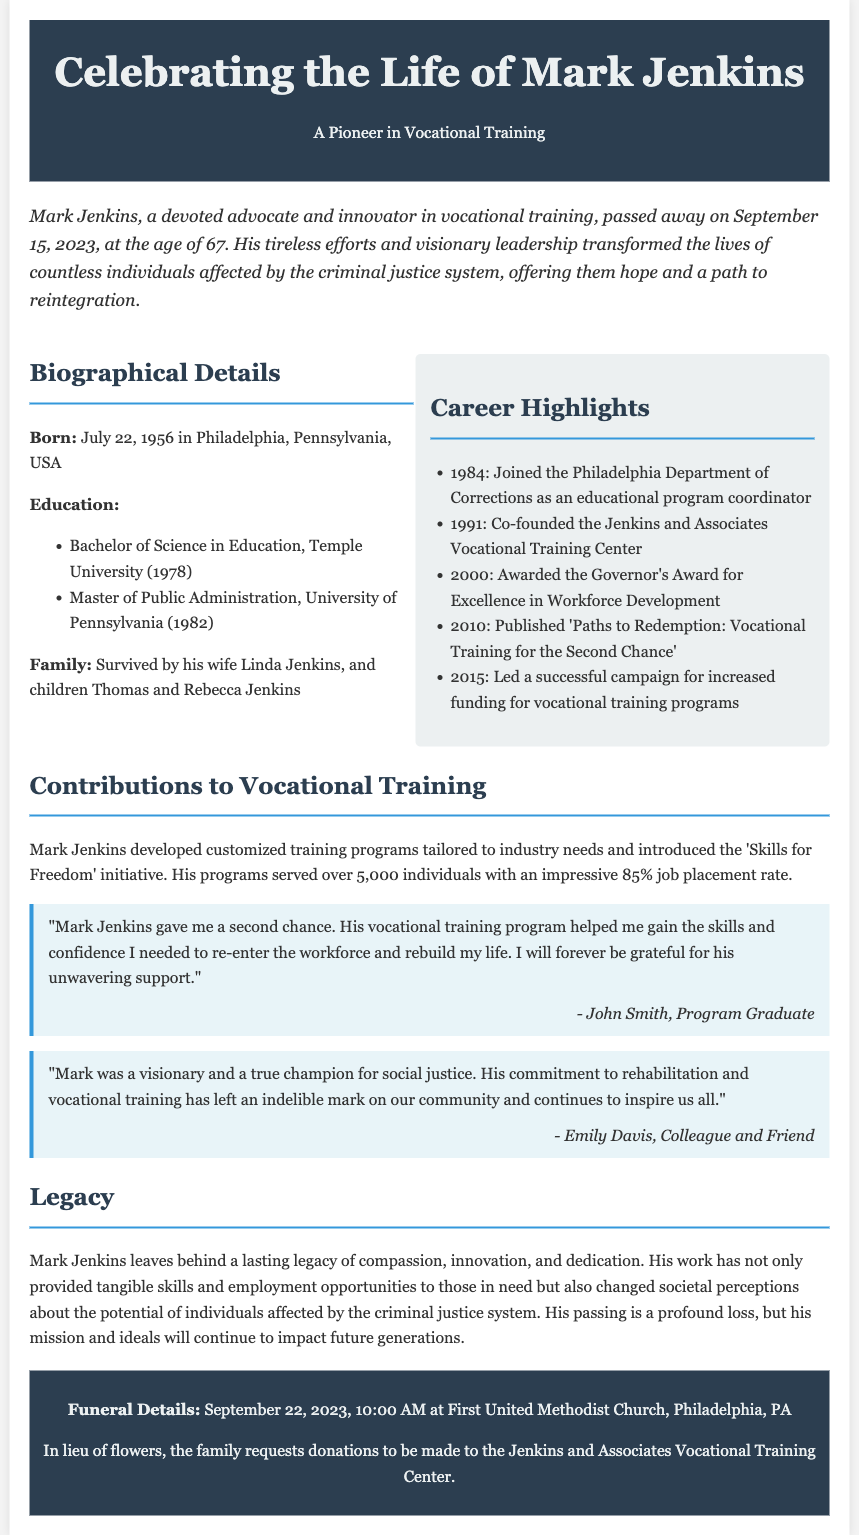what was Mark Jenkins' age at the time of his passing? Mark Jenkins passed away at the age of 67 on September 15, 2023.
Answer: 67 what initiative did Mark Jenkins introduce? The document mentions the 'Skills for Freedom' initiative as introduced by Mark Jenkins.
Answer: Skills for Freedom which university did Mark Jenkins attend for his undergraduate degree? The obituary lists Temple University as the institution where he received his Bachelor's degree in Education.
Answer: Temple University how many individuals benefited from Mark Jenkins' programs? According to the document, over 5,000 individuals were served by his programs.
Answer: 5,000 when is the funeral service scheduled? The funeral details specify that it is on September 22, 2023, at 10:00 AM.
Answer: September 22, 2023 what was the job placement rate for the vocational training programs? The document states that the job placement rate was 85%.
Answer: 85% who is Mark Jenkins' surviving spouse? The document mentions Linda Jenkins as his surviving spouse.
Answer: Linda Jenkins which award did Mark Jenkins receive in 2000? The Governor's Award for Excellence in Workforce Development is mentioned as an award he received.
Answer: Governor's Award for Excellence in Workforce Development what types of programs did Mark Jenkins focus on? The obituary indicates that he focused on vocational training programs tailored to individuals affected by the criminal justice system.
Answer: Vocational training programs 